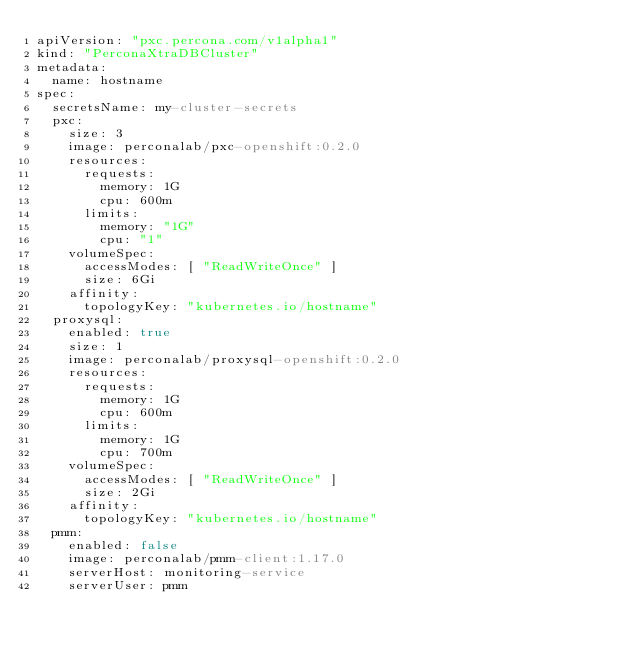Convert code to text. <code><loc_0><loc_0><loc_500><loc_500><_YAML_>apiVersion: "pxc.percona.com/v1alpha1"
kind: "PerconaXtraDBCluster"
metadata:
  name: hostname
spec:
  secretsName: my-cluster-secrets
  pxc:
    size: 3
    image: perconalab/pxc-openshift:0.2.0
    resources:
      requests:
        memory: 1G
        cpu: 600m
      limits:
        memory: "1G"
        cpu: "1"
    volumeSpec:
      accessModes: [ "ReadWriteOnce" ]
      size: 6Gi
    affinity:
      topologyKey: "kubernetes.io/hostname"
  proxysql:
    enabled: true
    size: 1
    image: perconalab/proxysql-openshift:0.2.0
    resources:
      requests:
        memory: 1G
        cpu: 600m
      limits:
        memory: 1G
        cpu: 700m
    volumeSpec:
      accessModes: [ "ReadWriteOnce" ]
      size: 2Gi
    affinity:
      topologyKey: "kubernetes.io/hostname"
  pmm:
    enabled: false
    image: perconalab/pmm-client:1.17.0
    serverHost: monitoring-service
    serverUser: pmm
</code> 